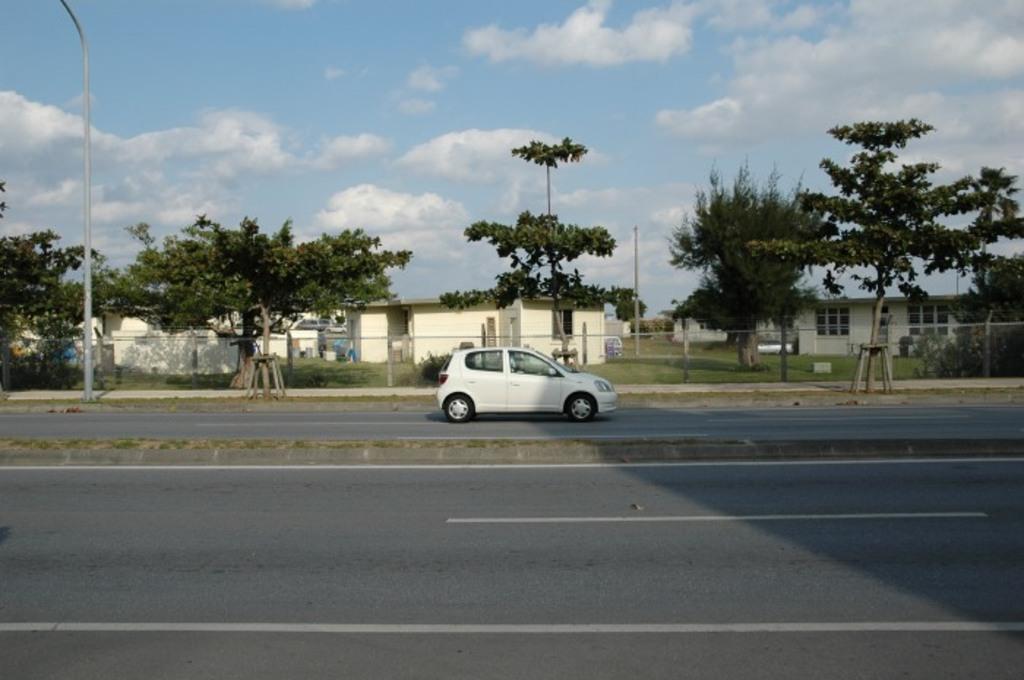Please provide a concise description of this image. In this image I see the roads and I see a car over here and in the background I see number of trees and number of buildings and I see the grass and I see the clear sky and I see a pole over here. 